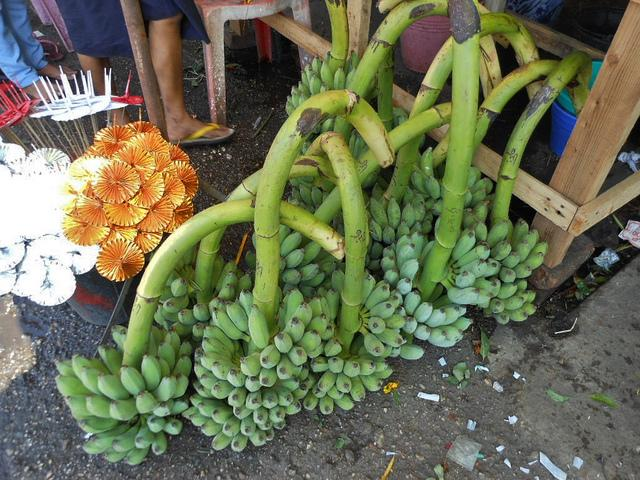What is the brown post behind the green fruit made of? wood 